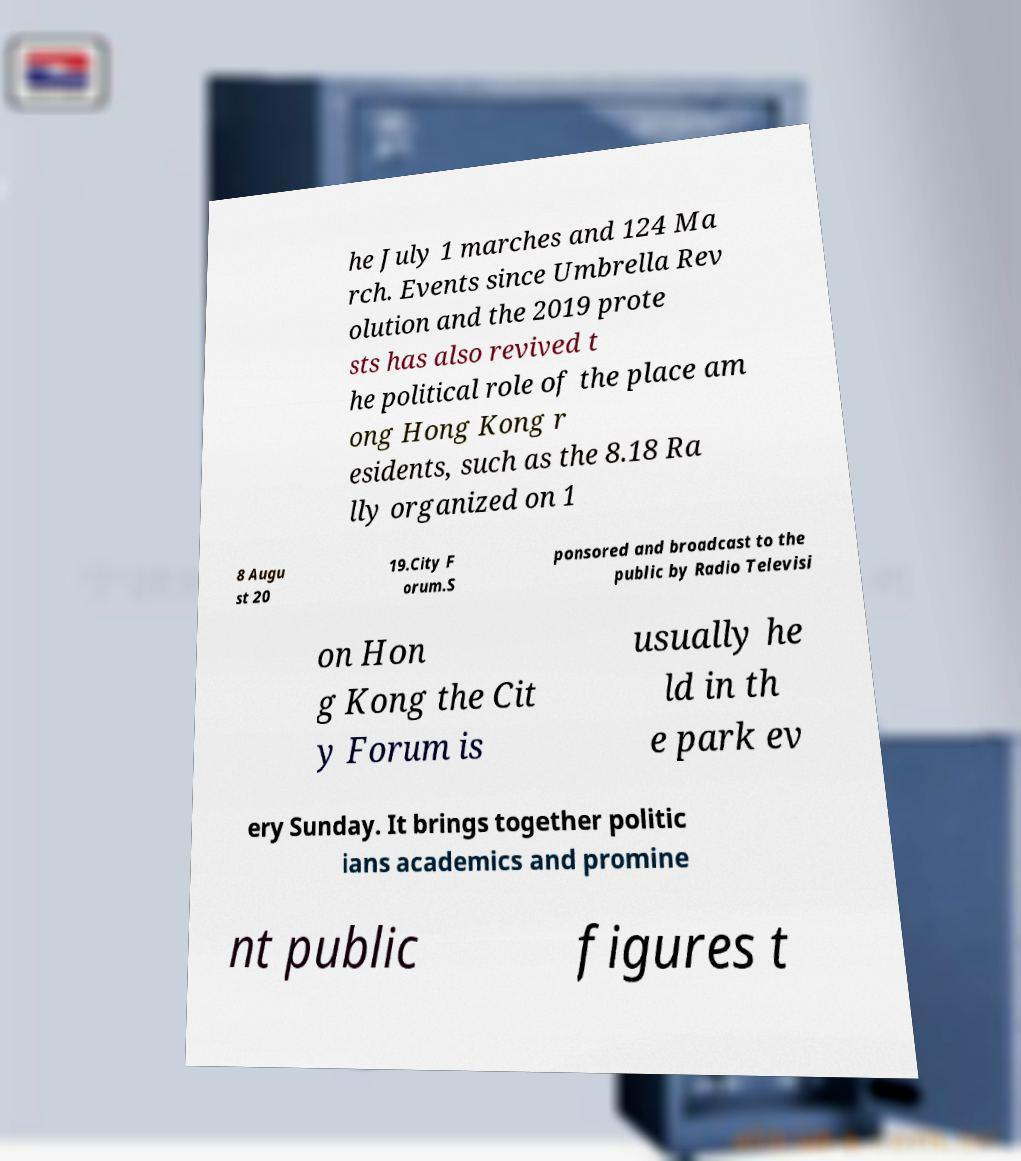Please identify and transcribe the text found in this image. he July 1 marches and 124 Ma rch. Events since Umbrella Rev olution and the 2019 prote sts has also revived t he political role of the place am ong Hong Kong r esidents, such as the 8.18 Ra lly organized on 1 8 Augu st 20 19.City F orum.S ponsored and broadcast to the public by Radio Televisi on Hon g Kong the Cit y Forum is usually he ld in th e park ev ery Sunday. It brings together politic ians academics and promine nt public figures t 